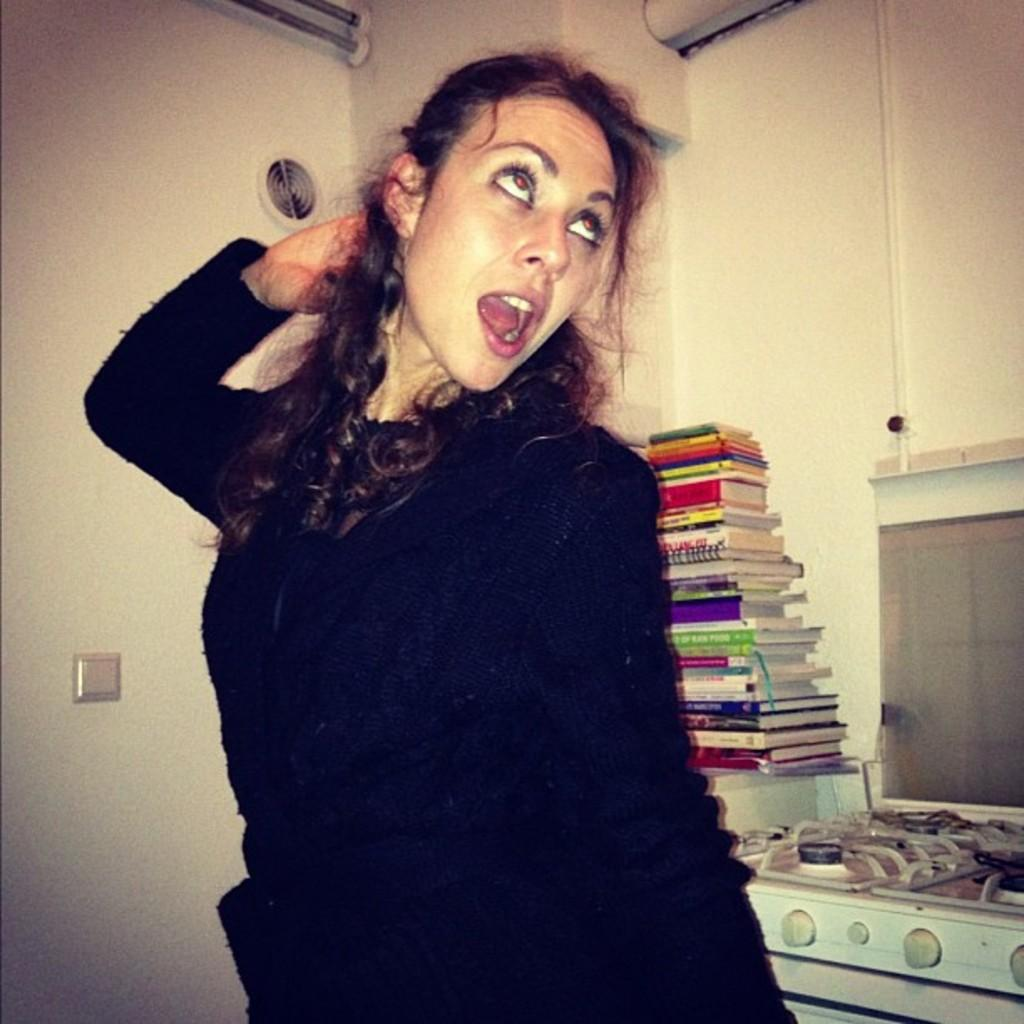Who is present in the image? There is a woman in the image. What is the woman wearing? The woman is wearing a black dress. What can be seen in the background of the image? There are books, a stove, and a switch board fixed to the wall in the background of the image. What type of stem can be seen in the image? There is no stem present in the image. 